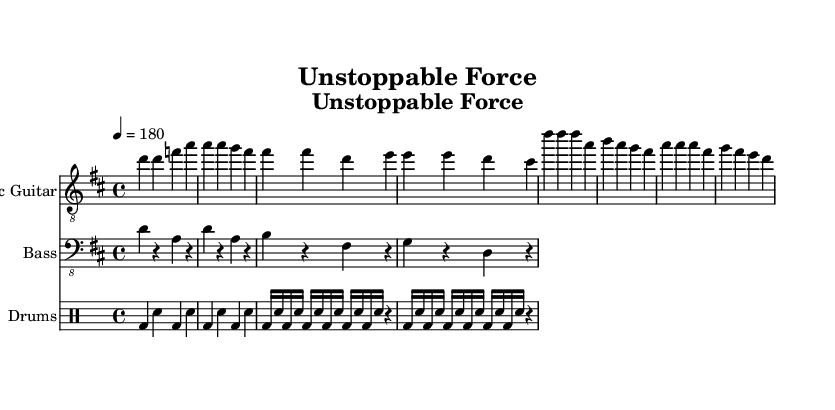What is the key signature of this music? The key signature is represented by the number of sharps or flats shown at the beginning of the staff. In this case, it shows 'two sharps', indicating that the music is in D major.
Answer: D major What is the time signature of this piece? The time signature appears at the beginning, represented as '4/4', which indicates that there are four beats in a measure and the quarter note gets one beat.
Answer: 4/4 What is the tempo marking of this composition? The tempo marking is found near the beginning, depicted as '4 = 180', meaning the piece is to be played at a speed of 180 beats per minute.
Answer: 180 How many measures are there in the verse section? By counting the number of measures from the verse notation, one can see that there are four measures in the verse section.
Answer: 4 What chords might accompany the electric guitar in the chorus section? Analyzing the melody from the chorus, one would expect power chords, such as D, A, B, and G, typically found in punk music, to accompany the highlighted melody notes.
Answer: D, A, B, G How does the rhythm of the drums contribute to the punk style? The drum part exhibits a straightforward and driving rhythm with bass and snare patterns that emphasize beats one and three, characteristic of punk's energetic style.
Answer: Driving rhythm What theme do the lyrics convey? The lyrics focus on empowerment and breaking boundaries, which aligns with the idea of celebrating disability pride and resilience.
Answer: Empowerment 